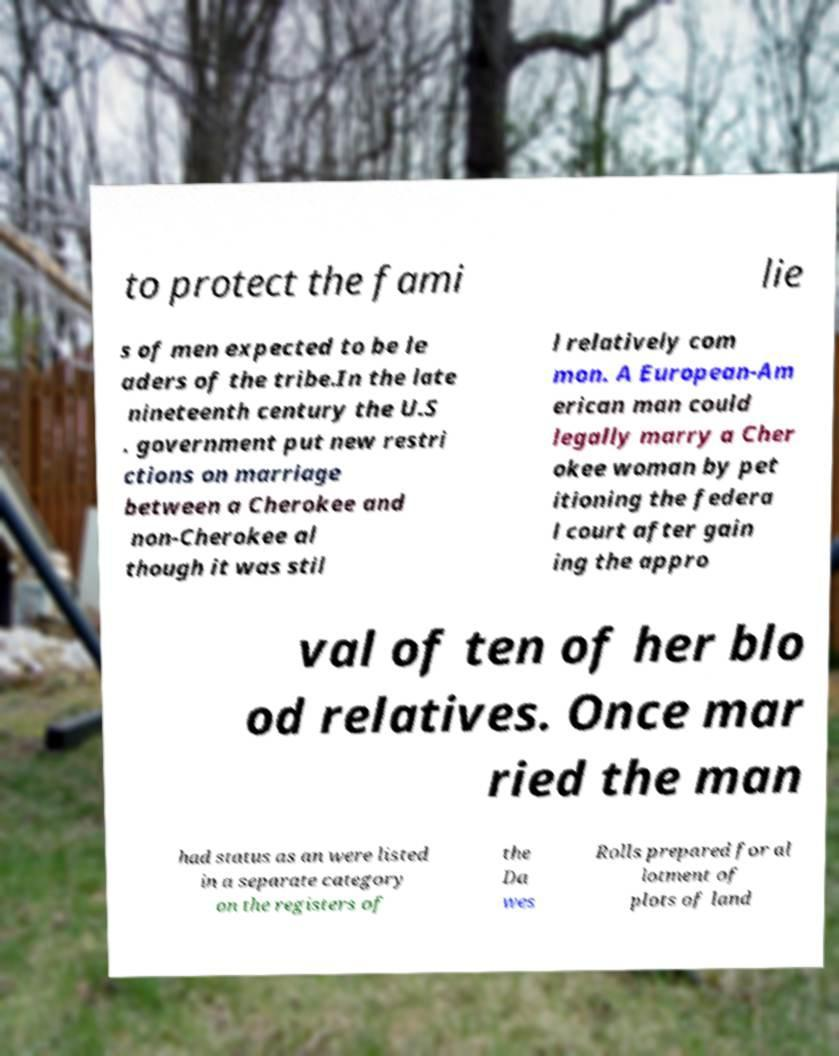Could you extract and type out the text from this image? to protect the fami lie s of men expected to be le aders of the tribe.In the late nineteenth century the U.S . government put new restri ctions on marriage between a Cherokee and non-Cherokee al though it was stil l relatively com mon. A European-Am erican man could legally marry a Cher okee woman by pet itioning the federa l court after gain ing the appro val of ten of her blo od relatives. Once mar ried the man had status as an were listed in a separate category on the registers of the Da wes Rolls prepared for al lotment of plots of land 